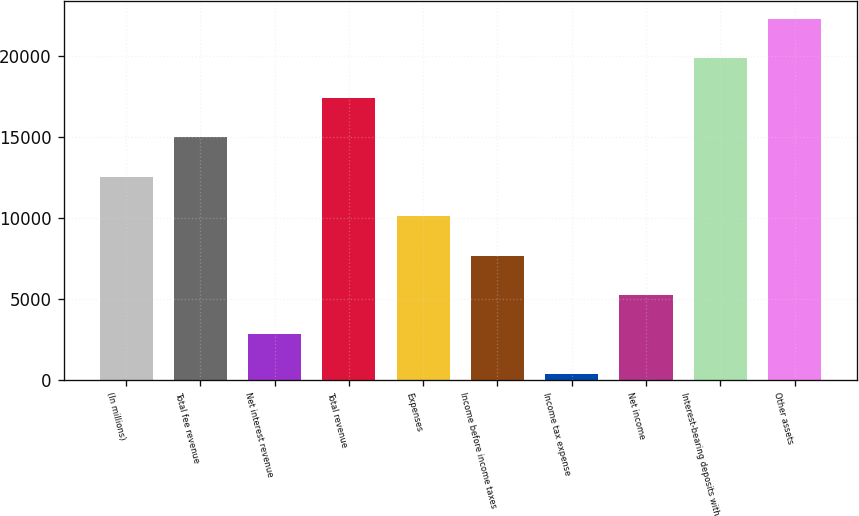Convert chart to OTSL. <chart><loc_0><loc_0><loc_500><loc_500><bar_chart><fcel>(In millions)<fcel>Total fee revenue<fcel>Net interest revenue<fcel>Total revenue<fcel>Expenses<fcel>Income before income taxes<fcel>Income tax expense<fcel>Net income<fcel>Interest-bearing deposits with<fcel>Other assets<nl><fcel>12524.5<fcel>14960.2<fcel>2781.7<fcel>17395.9<fcel>10088.8<fcel>7653.1<fcel>346<fcel>5217.4<fcel>19831.6<fcel>22267.3<nl></chart> 